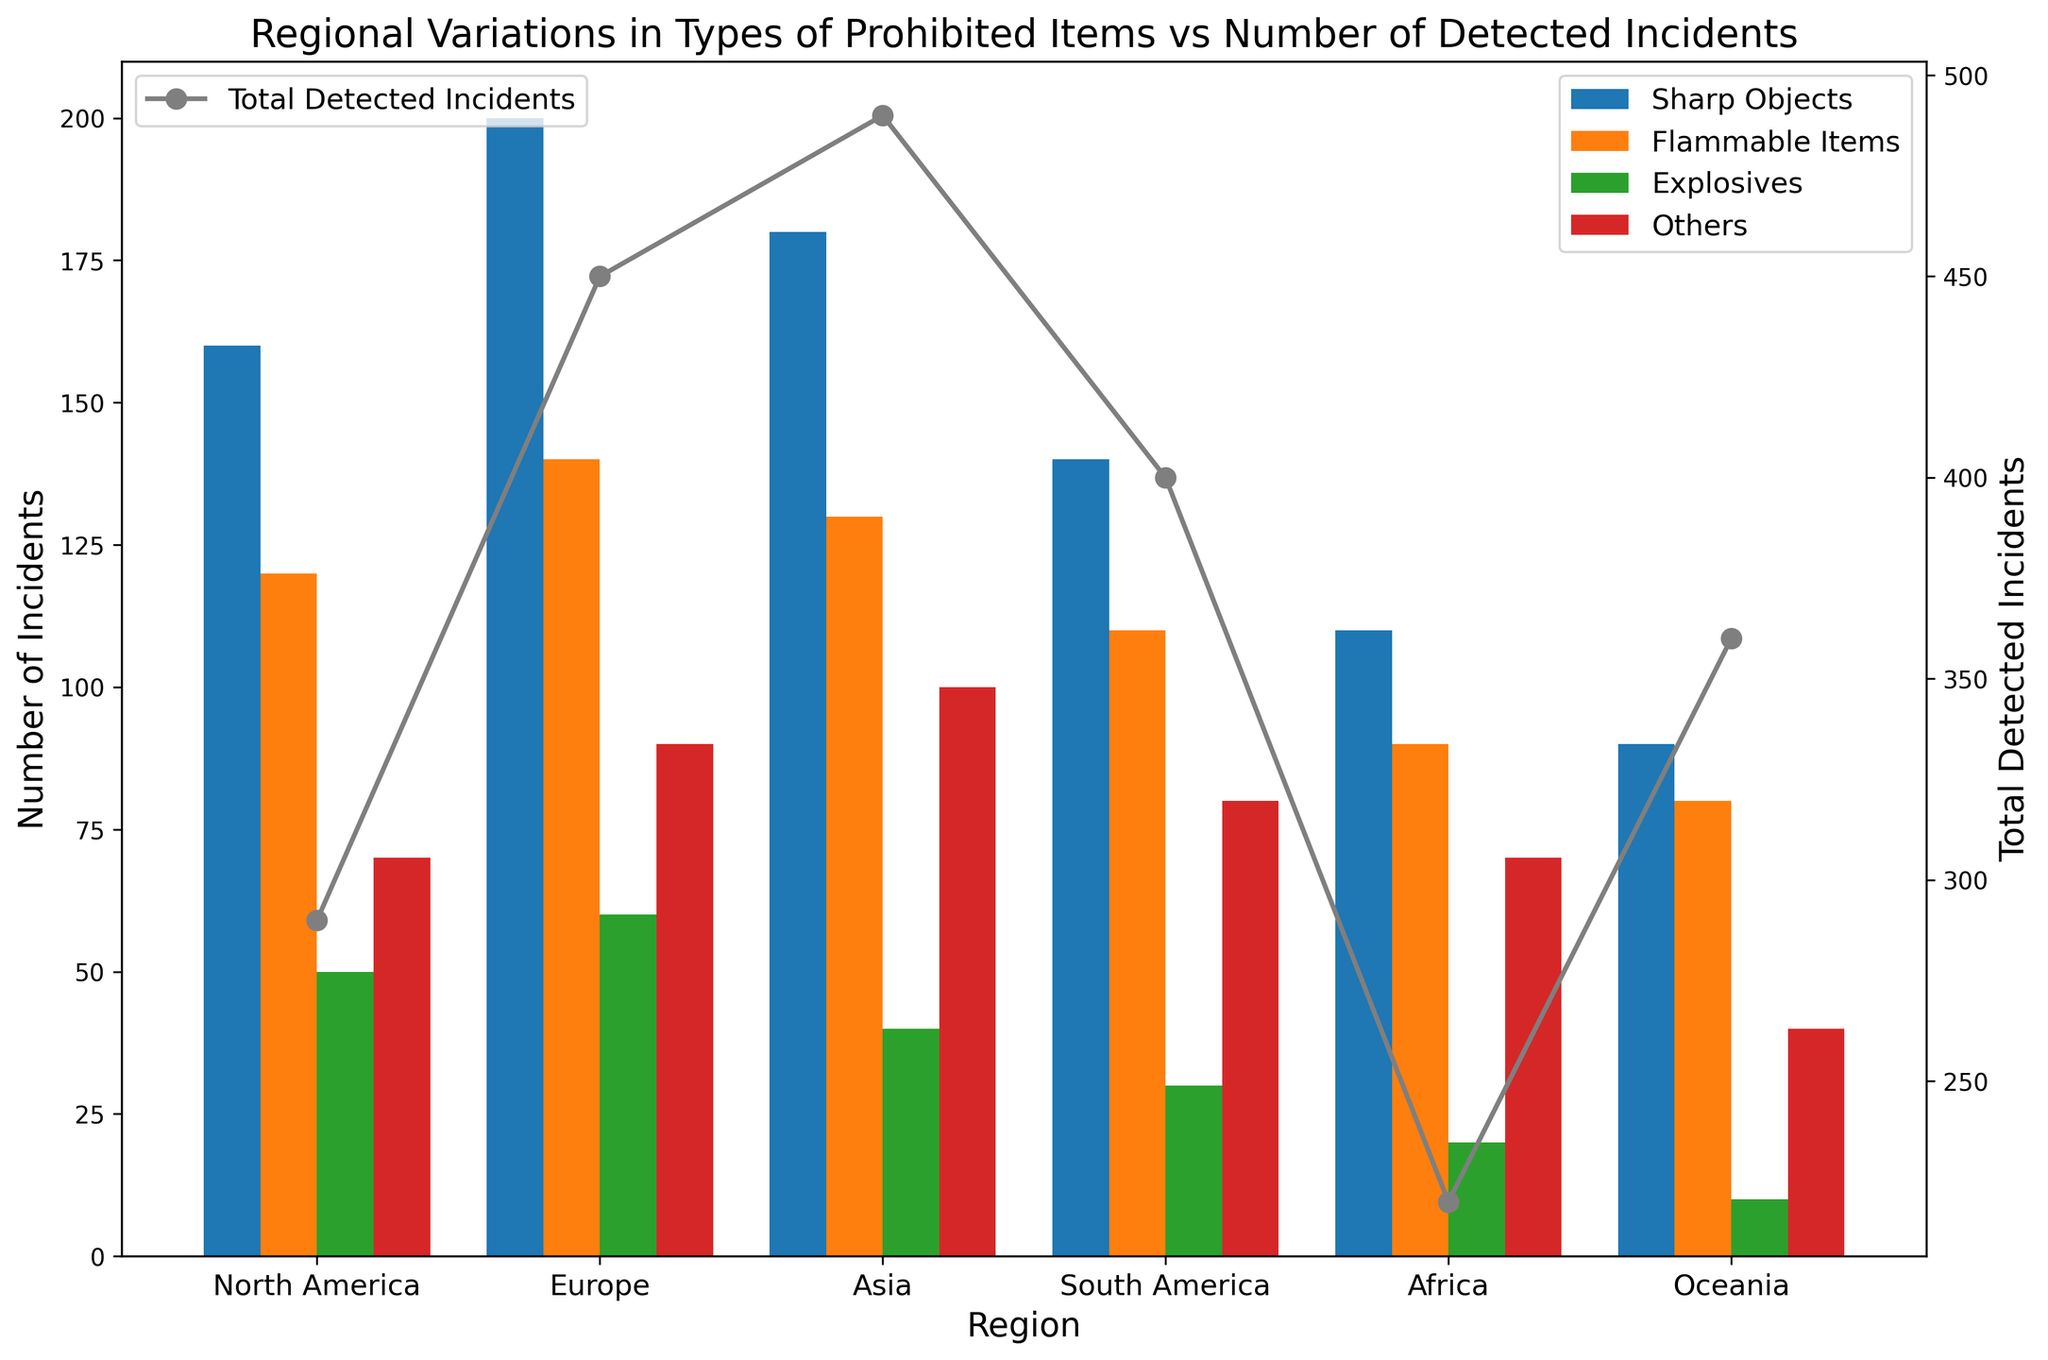What region has the highest number of incidents involving sharp objects? First, identify the different colored bars representing sharp objects for each region. From the visual cues, determine that the highest bar for sharp objects is in Europe.
Answer: Europe Which region has the lowest total detected incidents? Look at the peak of the grey line which represents the total detected incidents for each region. The shortest peak is in Oceania.
Answer: Oceania What is the difference in the number of incidents involving flammable items between Europe and Oceania? Compare the height of the flammable items bar (orange) for Europe and Oceania. Europe has 140, and Oceania has 80; thus, the difference is 60.
Answer: 60 How many explosive-related incidents are detected in North America and Oceania combined? Check the height of the green bars representing explosive-related incidents in North America and Oceania. North America has 50, and Oceania has 10, summing up to 60.
Answer: 60 What region has the largest proportion of 'Others' incidents relative to its total detected incidents? For each region, find the 'Others' incidents (red bar) and the respective total detected incidents (grey point). Calculate the proportion by dividing the number for 'Others' by the total for each region and check which proportion is highest. Asia has the highest value with 100 incidents out of 450 total incidents (22.2%).
Answer: Asia Which prohibited item type has the most uniform distribution across all regions? Visually compare the bars of each color across all regions for uniform height. The 'Explosives' (green) bars show the most uniform distribution.
Answer: Explosives If we combine the incidents involving flammable items and others in Africa, what is the total? Add the numbers from the bars representing flammable items (90) and others (70) in Africa. The sum is 160.
Answer: 160 Which region has the closest number of total detected incidents to 400? Compare total detected incidents (grey points) against 400. North America has exactly 400.
Answer: North America By how much do the total detected incidents in Asia exceed those in Africa? Subtract the total detected incidents in Africa (290) from those in Asia (450). The difference is 160.
Answer: 160 In which region is the discrepancy between sharp objects and explosives incidents the greatest? Calculate the difference in incidents between sharp objects and explosives for each region. The greatest difference (140) is in Europe (200 - 60).
Answer: Europe 